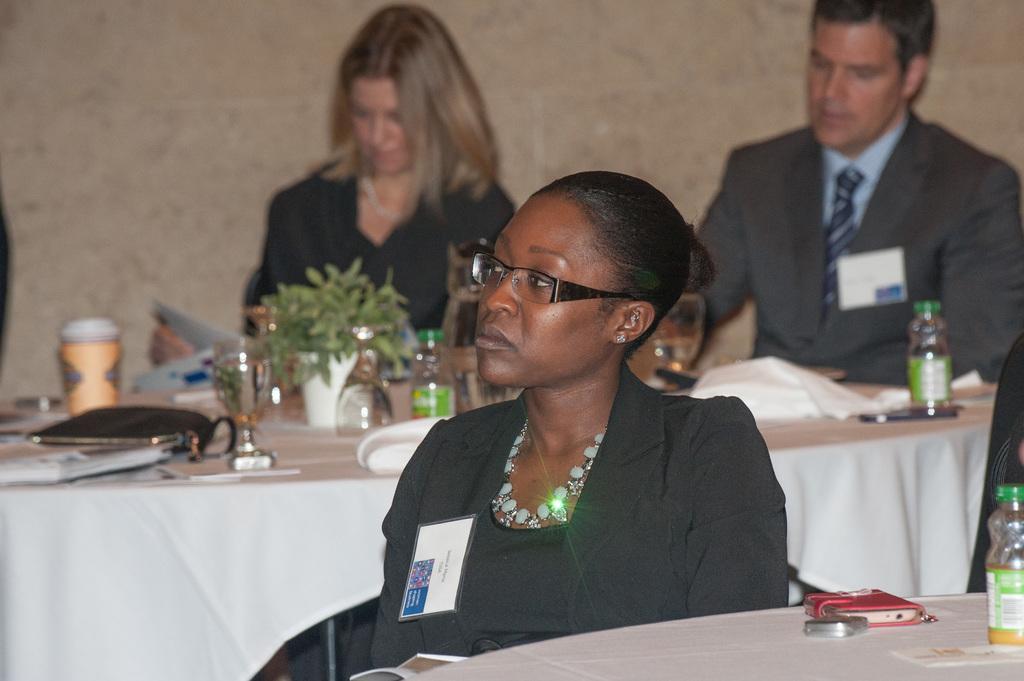Describe this image in one or two sentences. In this image we can see a woman sitting and there is a table with a bottle and some other things. We can see two persons sitting in the background and there is a table in front of them and we can see few glasses, bottles and some other objects on the table. 